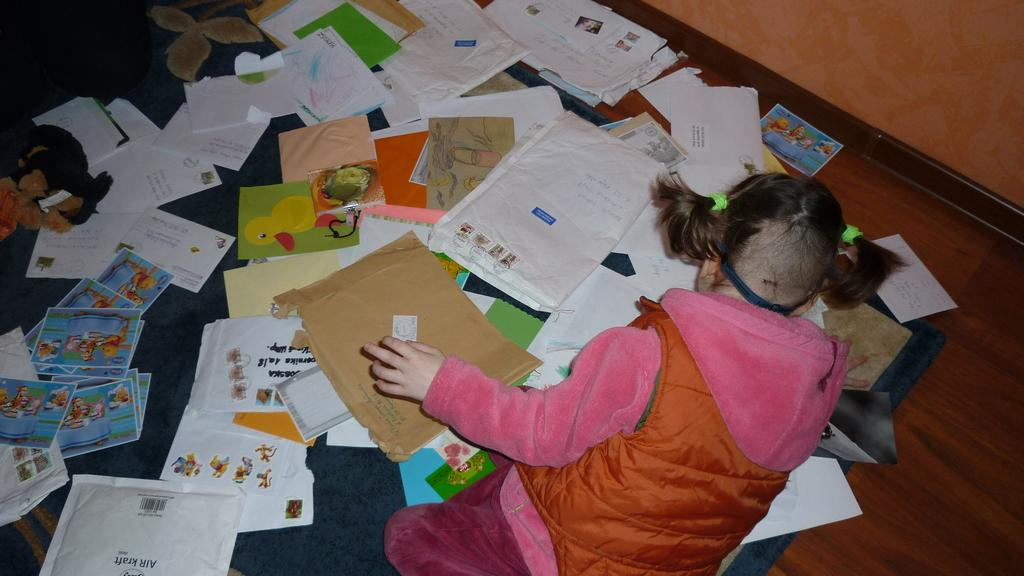What is the main subject of the picture? The main subject of the picture is a kid. What can be seen on the floor in the image? There are papers and other objects on the floor in the image. What is visible in the background of the picture? There is a wall in the background of the picture. What type of silk material is draped over the kid in the image? There is no silk material present in the image; the kid is not wearing or holding any fabric. 